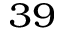Convert formula to latex. <formula><loc_0><loc_0><loc_500><loc_500>^ { 3 9 }</formula> 